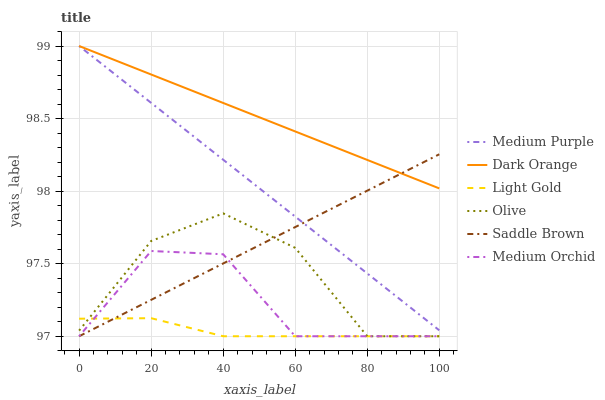Does Light Gold have the minimum area under the curve?
Answer yes or no. Yes. Does Dark Orange have the maximum area under the curve?
Answer yes or no. Yes. Does Medium Orchid have the minimum area under the curve?
Answer yes or no. No. Does Medium Orchid have the maximum area under the curve?
Answer yes or no. No. Is Medium Purple the smoothest?
Answer yes or no. Yes. Is Olive the roughest?
Answer yes or no. Yes. Is Medium Orchid the smoothest?
Answer yes or no. No. Is Medium Orchid the roughest?
Answer yes or no. No. Does Medium Purple have the lowest value?
Answer yes or no. No. Does Medium Purple have the highest value?
Answer yes or no. Yes. Does Medium Orchid have the highest value?
Answer yes or no. No. Is Olive less than Dark Orange?
Answer yes or no. Yes. Is Medium Purple greater than Light Gold?
Answer yes or no. Yes. Does Medium Orchid intersect Olive?
Answer yes or no. Yes. Is Medium Orchid less than Olive?
Answer yes or no. No. Is Medium Orchid greater than Olive?
Answer yes or no. No. Does Olive intersect Dark Orange?
Answer yes or no. No. 